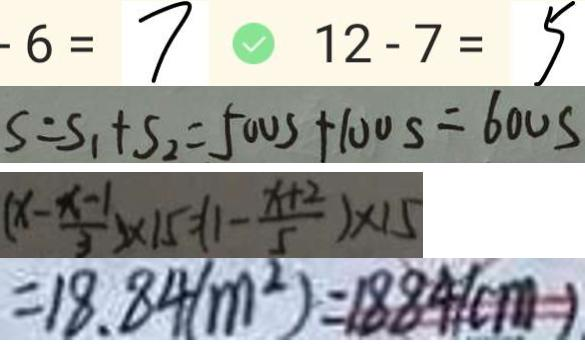Convert formula to latex. <formula><loc_0><loc_0><loc_500><loc_500>- 6 = 7 1 2 - 7 = 5 
 S = S _ { 1 } + S _ { 2 } = 5 0 0 s + 1 0 0 s = 6 0 0 s 
 ( x - \frac { x - 1 } { 3 } ) \times 1 5 = 1 - \frac { x + 2 } { 5 } ) \times 1 5 
 = 1 8 . 8 4 ( m ^ { 2 } ) = 1 8 8 4 ( c m )</formula> 